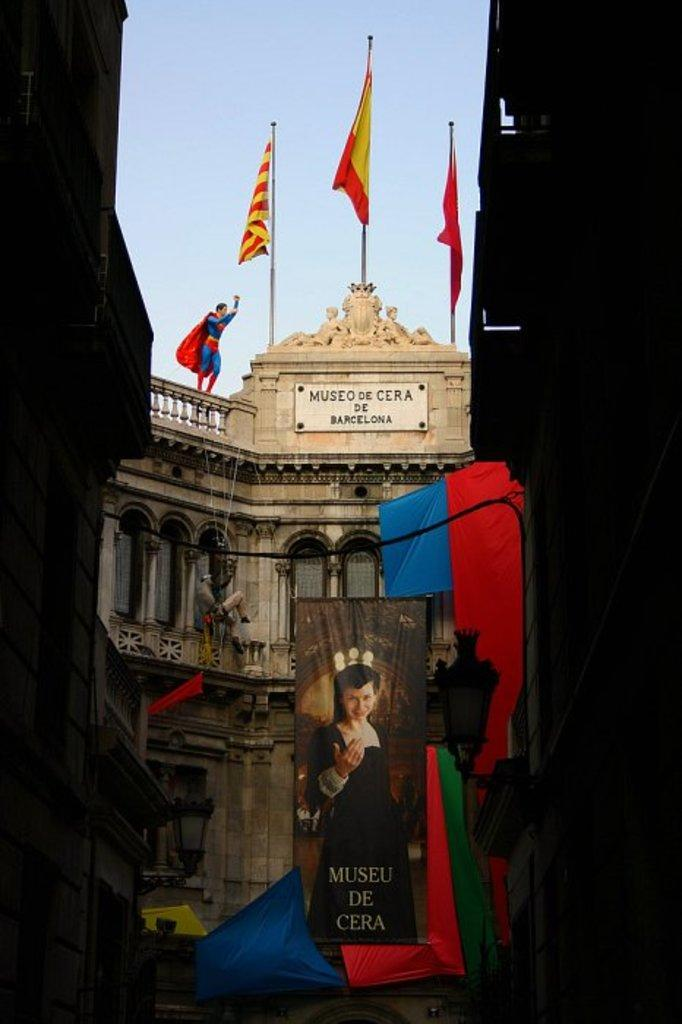What is located in the center of the image? There are buildings, banners, and flags in the center of the image. What is on top of one of the buildings? There is a statue of a superman on top of top of a building. What can be seen in the background of the image? The sky is visible in the background of the image. What type of breakfast is being served at the uncle's house in the image? There is no uncle or breakfast present in the image. Is there a slope visible in the image? There is no slope visible in the image. 